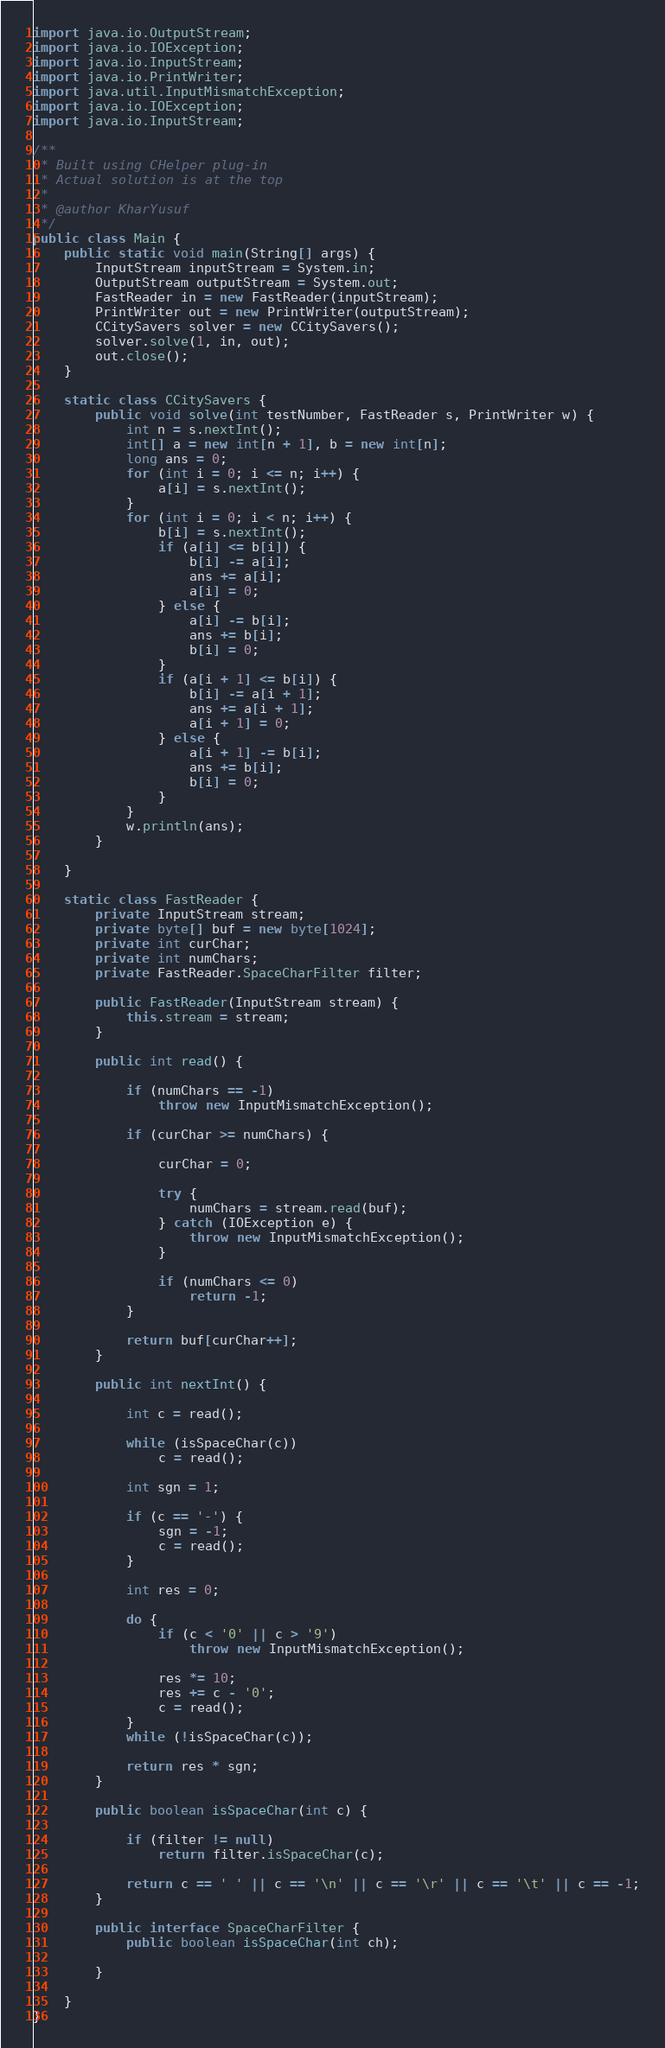Convert code to text. <code><loc_0><loc_0><loc_500><loc_500><_Java_>import java.io.OutputStream;
import java.io.IOException;
import java.io.InputStream;
import java.io.PrintWriter;
import java.util.InputMismatchException;
import java.io.IOException;
import java.io.InputStream;

/**
 * Built using CHelper plug-in
 * Actual solution is at the top
 *
 * @author KharYusuf
 */
public class Main {
    public static void main(String[] args) {
        InputStream inputStream = System.in;
        OutputStream outputStream = System.out;
        FastReader in = new FastReader(inputStream);
        PrintWriter out = new PrintWriter(outputStream);
        CCitySavers solver = new CCitySavers();
        solver.solve(1, in, out);
        out.close();
    }

    static class CCitySavers {
        public void solve(int testNumber, FastReader s, PrintWriter w) {
            int n = s.nextInt();
            int[] a = new int[n + 1], b = new int[n];
            long ans = 0;
            for (int i = 0; i <= n; i++) {
                a[i] = s.nextInt();
            }
            for (int i = 0; i < n; i++) {
                b[i] = s.nextInt();
                if (a[i] <= b[i]) {
                    b[i] -= a[i];
                    ans += a[i];
                    a[i] = 0;
                } else {
                    a[i] -= b[i];
                    ans += b[i];
                    b[i] = 0;
                }
                if (a[i + 1] <= b[i]) {
                    b[i] -= a[i + 1];
                    ans += a[i + 1];
                    a[i + 1] = 0;
                } else {
                    a[i + 1] -= b[i];
                    ans += b[i];
                    b[i] = 0;
                }
            }
            w.println(ans);
        }

    }

    static class FastReader {
        private InputStream stream;
        private byte[] buf = new byte[1024];
        private int curChar;
        private int numChars;
        private FastReader.SpaceCharFilter filter;

        public FastReader(InputStream stream) {
            this.stream = stream;
        }

        public int read() {

            if (numChars == -1)
                throw new InputMismatchException();

            if (curChar >= numChars) {

                curChar = 0;

                try {
                    numChars = stream.read(buf);
                } catch (IOException e) {
                    throw new InputMismatchException();
                }

                if (numChars <= 0)
                    return -1;
            }

            return buf[curChar++];
        }

        public int nextInt() {

            int c = read();

            while (isSpaceChar(c))
                c = read();

            int sgn = 1;

            if (c == '-') {
                sgn = -1;
                c = read();
            }

            int res = 0;

            do {
                if (c < '0' || c > '9')
                    throw new InputMismatchException();

                res *= 10;
                res += c - '0';
                c = read();
            }
            while (!isSpaceChar(c));

            return res * sgn;
        }

        public boolean isSpaceChar(int c) {

            if (filter != null)
                return filter.isSpaceChar(c);

            return c == ' ' || c == '\n' || c == '\r' || c == '\t' || c == -1;
        }

        public interface SpaceCharFilter {
            public boolean isSpaceChar(int ch);

        }

    }
}

</code> 